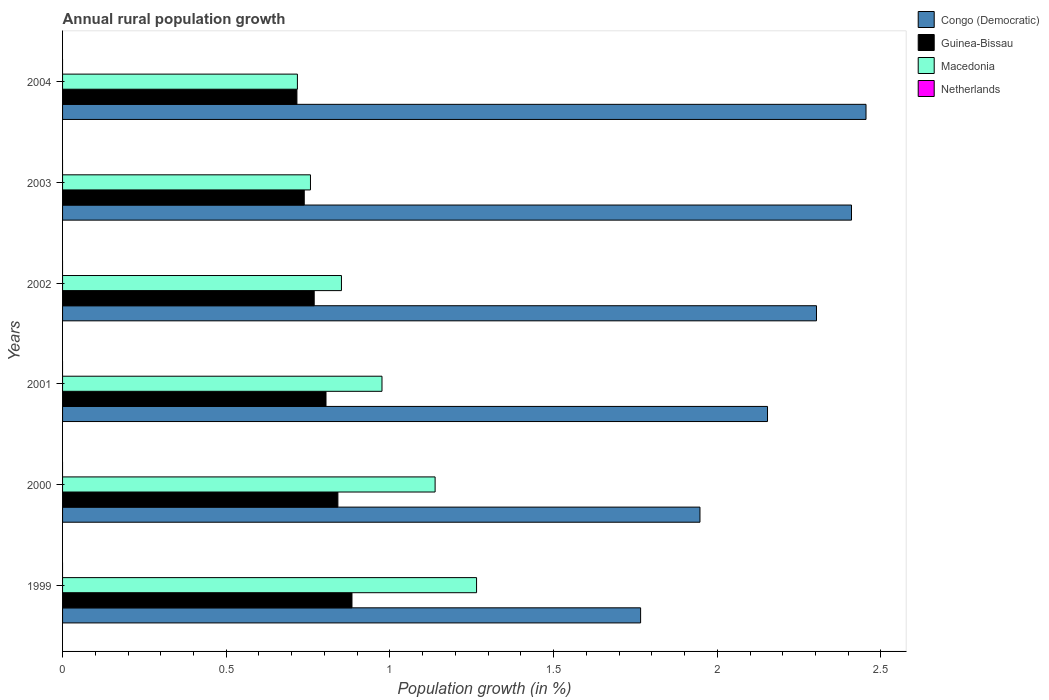How many bars are there on the 6th tick from the top?
Your response must be concise. 3. How many bars are there on the 2nd tick from the bottom?
Provide a short and direct response. 3. In how many cases, is the number of bars for a given year not equal to the number of legend labels?
Offer a very short reply. 6. What is the percentage of rural population growth in Netherlands in 2000?
Offer a very short reply. 0. Across all years, what is the maximum percentage of rural population growth in Macedonia?
Give a very brief answer. 1.26. Across all years, what is the minimum percentage of rural population growth in Congo (Democratic)?
Provide a short and direct response. 1.77. What is the total percentage of rural population growth in Guinea-Bissau in the graph?
Provide a succinct answer. 4.75. What is the difference between the percentage of rural population growth in Macedonia in 1999 and that in 2000?
Provide a succinct answer. 0.13. What is the difference between the percentage of rural population growth in Macedonia in 1999 and the percentage of rural population growth in Netherlands in 2003?
Make the answer very short. 1.26. What is the average percentage of rural population growth in Macedonia per year?
Your response must be concise. 0.95. In the year 2002, what is the difference between the percentage of rural population growth in Guinea-Bissau and percentage of rural population growth in Macedonia?
Your answer should be very brief. -0.08. In how many years, is the percentage of rural population growth in Guinea-Bissau greater than 1.1 %?
Keep it short and to the point. 0. What is the ratio of the percentage of rural population growth in Congo (Democratic) in 1999 to that in 2003?
Give a very brief answer. 0.73. Is the percentage of rural population growth in Macedonia in 2000 less than that in 2002?
Keep it short and to the point. No. Is the difference between the percentage of rural population growth in Guinea-Bissau in 2003 and 2004 greater than the difference between the percentage of rural population growth in Macedonia in 2003 and 2004?
Your response must be concise. No. What is the difference between the highest and the second highest percentage of rural population growth in Congo (Democratic)?
Make the answer very short. 0.04. What is the difference between the highest and the lowest percentage of rural population growth in Congo (Democratic)?
Offer a terse response. 0.69. In how many years, is the percentage of rural population growth in Guinea-Bissau greater than the average percentage of rural population growth in Guinea-Bissau taken over all years?
Your answer should be compact. 3. Is it the case that in every year, the sum of the percentage of rural population growth in Guinea-Bissau and percentage of rural population growth in Netherlands is greater than the sum of percentage of rural population growth in Macedonia and percentage of rural population growth in Congo (Democratic)?
Make the answer very short. No. Is it the case that in every year, the sum of the percentage of rural population growth in Guinea-Bissau and percentage of rural population growth in Netherlands is greater than the percentage of rural population growth in Congo (Democratic)?
Provide a succinct answer. No. Are all the bars in the graph horizontal?
Ensure brevity in your answer.  Yes. How many years are there in the graph?
Offer a terse response. 6. Does the graph contain any zero values?
Your answer should be compact. Yes. How are the legend labels stacked?
Make the answer very short. Vertical. What is the title of the graph?
Keep it short and to the point. Annual rural population growth. What is the label or title of the X-axis?
Provide a short and direct response. Population growth (in %). What is the label or title of the Y-axis?
Provide a succinct answer. Years. What is the Population growth (in %) of Congo (Democratic) in 1999?
Offer a terse response. 1.77. What is the Population growth (in %) in Guinea-Bissau in 1999?
Your answer should be compact. 0.88. What is the Population growth (in %) in Macedonia in 1999?
Ensure brevity in your answer.  1.26. What is the Population growth (in %) of Congo (Democratic) in 2000?
Your answer should be compact. 1.95. What is the Population growth (in %) of Guinea-Bissau in 2000?
Provide a short and direct response. 0.84. What is the Population growth (in %) of Macedonia in 2000?
Your answer should be compact. 1.14. What is the Population growth (in %) of Netherlands in 2000?
Offer a terse response. 0. What is the Population growth (in %) in Congo (Democratic) in 2001?
Your response must be concise. 2.15. What is the Population growth (in %) in Guinea-Bissau in 2001?
Provide a short and direct response. 0.8. What is the Population growth (in %) of Macedonia in 2001?
Your response must be concise. 0.98. What is the Population growth (in %) of Netherlands in 2001?
Your answer should be compact. 0. What is the Population growth (in %) in Congo (Democratic) in 2002?
Give a very brief answer. 2.3. What is the Population growth (in %) of Guinea-Bissau in 2002?
Your answer should be very brief. 0.77. What is the Population growth (in %) of Macedonia in 2002?
Your answer should be very brief. 0.85. What is the Population growth (in %) in Netherlands in 2002?
Make the answer very short. 0. What is the Population growth (in %) in Congo (Democratic) in 2003?
Keep it short and to the point. 2.41. What is the Population growth (in %) in Guinea-Bissau in 2003?
Your response must be concise. 0.74. What is the Population growth (in %) in Macedonia in 2003?
Make the answer very short. 0.76. What is the Population growth (in %) of Netherlands in 2003?
Keep it short and to the point. 0. What is the Population growth (in %) in Congo (Democratic) in 2004?
Make the answer very short. 2.45. What is the Population growth (in %) in Guinea-Bissau in 2004?
Provide a short and direct response. 0.72. What is the Population growth (in %) in Macedonia in 2004?
Offer a very short reply. 0.72. Across all years, what is the maximum Population growth (in %) in Congo (Democratic)?
Give a very brief answer. 2.45. Across all years, what is the maximum Population growth (in %) in Guinea-Bissau?
Offer a very short reply. 0.88. Across all years, what is the maximum Population growth (in %) in Macedonia?
Provide a short and direct response. 1.26. Across all years, what is the minimum Population growth (in %) of Congo (Democratic)?
Keep it short and to the point. 1.77. Across all years, what is the minimum Population growth (in %) of Guinea-Bissau?
Your answer should be very brief. 0.72. Across all years, what is the minimum Population growth (in %) in Macedonia?
Keep it short and to the point. 0.72. What is the total Population growth (in %) of Congo (Democratic) in the graph?
Offer a terse response. 13.03. What is the total Population growth (in %) in Guinea-Bissau in the graph?
Provide a short and direct response. 4.75. What is the total Population growth (in %) in Macedonia in the graph?
Your response must be concise. 5.71. What is the difference between the Population growth (in %) of Congo (Democratic) in 1999 and that in 2000?
Offer a very short reply. -0.18. What is the difference between the Population growth (in %) in Guinea-Bissau in 1999 and that in 2000?
Give a very brief answer. 0.04. What is the difference between the Population growth (in %) in Macedonia in 1999 and that in 2000?
Provide a short and direct response. 0.13. What is the difference between the Population growth (in %) of Congo (Democratic) in 1999 and that in 2001?
Keep it short and to the point. -0.39. What is the difference between the Population growth (in %) in Guinea-Bissau in 1999 and that in 2001?
Your answer should be very brief. 0.08. What is the difference between the Population growth (in %) in Macedonia in 1999 and that in 2001?
Ensure brevity in your answer.  0.29. What is the difference between the Population growth (in %) in Congo (Democratic) in 1999 and that in 2002?
Your response must be concise. -0.54. What is the difference between the Population growth (in %) of Guinea-Bissau in 1999 and that in 2002?
Provide a succinct answer. 0.12. What is the difference between the Population growth (in %) of Macedonia in 1999 and that in 2002?
Provide a short and direct response. 0.41. What is the difference between the Population growth (in %) of Congo (Democratic) in 1999 and that in 2003?
Offer a very short reply. -0.64. What is the difference between the Population growth (in %) of Guinea-Bissau in 1999 and that in 2003?
Your response must be concise. 0.15. What is the difference between the Population growth (in %) in Macedonia in 1999 and that in 2003?
Give a very brief answer. 0.51. What is the difference between the Population growth (in %) of Congo (Democratic) in 1999 and that in 2004?
Make the answer very short. -0.69. What is the difference between the Population growth (in %) of Guinea-Bissau in 1999 and that in 2004?
Your response must be concise. 0.17. What is the difference between the Population growth (in %) in Macedonia in 1999 and that in 2004?
Offer a terse response. 0.55. What is the difference between the Population growth (in %) of Congo (Democratic) in 2000 and that in 2001?
Ensure brevity in your answer.  -0.21. What is the difference between the Population growth (in %) of Guinea-Bissau in 2000 and that in 2001?
Make the answer very short. 0.04. What is the difference between the Population growth (in %) in Macedonia in 2000 and that in 2001?
Give a very brief answer. 0.16. What is the difference between the Population growth (in %) of Congo (Democratic) in 2000 and that in 2002?
Your answer should be compact. -0.36. What is the difference between the Population growth (in %) of Guinea-Bissau in 2000 and that in 2002?
Offer a very short reply. 0.07. What is the difference between the Population growth (in %) of Macedonia in 2000 and that in 2002?
Your response must be concise. 0.29. What is the difference between the Population growth (in %) of Congo (Democratic) in 2000 and that in 2003?
Give a very brief answer. -0.46. What is the difference between the Population growth (in %) of Guinea-Bissau in 2000 and that in 2003?
Make the answer very short. 0.1. What is the difference between the Population growth (in %) of Macedonia in 2000 and that in 2003?
Your answer should be compact. 0.38. What is the difference between the Population growth (in %) in Congo (Democratic) in 2000 and that in 2004?
Keep it short and to the point. -0.51. What is the difference between the Population growth (in %) in Guinea-Bissau in 2000 and that in 2004?
Keep it short and to the point. 0.13. What is the difference between the Population growth (in %) of Macedonia in 2000 and that in 2004?
Make the answer very short. 0.42. What is the difference between the Population growth (in %) of Congo (Democratic) in 2001 and that in 2002?
Provide a succinct answer. -0.15. What is the difference between the Population growth (in %) in Guinea-Bissau in 2001 and that in 2002?
Make the answer very short. 0.04. What is the difference between the Population growth (in %) in Macedonia in 2001 and that in 2002?
Provide a succinct answer. 0.12. What is the difference between the Population growth (in %) in Congo (Democratic) in 2001 and that in 2003?
Offer a terse response. -0.26. What is the difference between the Population growth (in %) in Guinea-Bissau in 2001 and that in 2003?
Make the answer very short. 0.07. What is the difference between the Population growth (in %) in Macedonia in 2001 and that in 2003?
Provide a short and direct response. 0.22. What is the difference between the Population growth (in %) in Congo (Democratic) in 2001 and that in 2004?
Your answer should be very brief. -0.3. What is the difference between the Population growth (in %) of Guinea-Bissau in 2001 and that in 2004?
Your answer should be very brief. 0.09. What is the difference between the Population growth (in %) of Macedonia in 2001 and that in 2004?
Ensure brevity in your answer.  0.26. What is the difference between the Population growth (in %) in Congo (Democratic) in 2002 and that in 2003?
Your answer should be compact. -0.11. What is the difference between the Population growth (in %) of Guinea-Bissau in 2002 and that in 2003?
Ensure brevity in your answer.  0.03. What is the difference between the Population growth (in %) of Macedonia in 2002 and that in 2003?
Offer a very short reply. 0.09. What is the difference between the Population growth (in %) of Congo (Democratic) in 2002 and that in 2004?
Provide a short and direct response. -0.15. What is the difference between the Population growth (in %) in Guinea-Bissau in 2002 and that in 2004?
Provide a short and direct response. 0.05. What is the difference between the Population growth (in %) in Macedonia in 2002 and that in 2004?
Your answer should be compact. 0.13. What is the difference between the Population growth (in %) in Congo (Democratic) in 2003 and that in 2004?
Your response must be concise. -0.04. What is the difference between the Population growth (in %) in Guinea-Bissau in 2003 and that in 2004?
Your answer should be compact. 0.02. What is the difference between the Population growth (in %) of Macedonia in 2003 and that in 2004?
Make the answer very short. 0.04. What is the difference between the Population growth (in %) of Congo (Democratic) in 1999 and the Population growth (in %) of Guinea-Bissau in 2000?
Provide a succinct answer. 0.92. What is the difference between the Population growth (in %) of Congo (Democratic) in 1999 and the Population growth (in %) of Macedonia in 2000?
Your response must be concise. 0.63. What is the difference between the Population growth (in %) of Guinea-Bissau in 1999 and the Population growth (in %) of Macedonia in 2000?
Provide a succinct answer. -0.25. What is the difference between the Population growth (in %) of Congo (Democratic) in 1999 and the Population growth (in %) of Guinea-Bissau in 2001?
Give a very brief answer. 0.96. What is the difference between the Population growth (in %) of Congo (Democratic) in 1999 and the Population growth (in %) of Macedonia in 2001?
Your answer should be compact. 0.79. What is the difference between the Population growth (in %) of Guinea-Bissau in 1999 and the Population growth (in %) of Macedonia in 2001?
Give a very brief answer. -0.09. What is the difference between the Population growth (in %) in Congo (Democratic) in 1999 and the Population growth (in %) in Guinea-Bissau in 2002?
Provide a succinct answer. 1. What is the difference between the Population growth (in %) of Congo (Democratic) in 1999 and the Population growth (in %) of Macedonia in 2002?
Offer a terse response. 0.91. What is the difference between the Population growth (in %) of Guinea-Bissau in 1999 and the Population growth (in %) of Macedonia in 2002?
Keep it short and to the point. 0.03. What is the difference between the Population growth (in %) in Congo (Democratic) in 1999 and the Population growth (in %) in Guinea-Bissau in 2003?
Make the answer very short. 1.03. What is the difference between the Population growth (in %) of Congo (Democratic) in 1999 and the Population growth (in %) of Macedonia in 2003?
Keep it short and to the point. 1.01. What is the difference between the Population growth (in %) in Guinea-Bissau in 1999 and the Population growth (in %) in Macedonia in 2003?
Ensure brevity in your answer.  0.13. What is the difference between the Population growth (in %) in Congo (Democratic) in 1999 and the Population growth (in %) in Guinea-Bissau in 2004?
Your answer should be very brief. 1.05. What is the difference between the Population growth (in %) in Congo (Democratic) in 1999 and the Population growth (in %) in Macedonia in 2004?
Provide a short and direct response. 1.05. What is the difference between the Population growth (in %) of Congo (Democratic) in 2000 and the Population growth (in %) of Guinea-Bissau in 2001?
Offer a very short reply. 1.14. What is the difference between the Population growth (in %) in Congo (Democratic) in 2000 and the Population growth (in %) in Macedonia in 2001?
Keep it short and to the point. 0.97. What is the difference between the Population growth (in %) in Guinea-Bissau in 2000 and the Population growth (in %) in Macedonia in 2001?
Make the answer very short. -0.13. What is the difference between the Population growth (in %) in Congo (Democratic) in 2000 and the Population growth (in %) in Guinea-Bissau in 2002?
Give a very brief answer. 1.18. What is the difference between the Population growth (in %) in Congo (Democratic) in 2000 and the Population growth (in %) in Macedonia in 2002?
Your answer should be very brief. 1.1. What is the difference between the Population growth (in %) of Guinea-Bissau in 2000 and the Population growth (in %) of Macedonia in 2002?
Your response must be concise. -0.01. What is the difference between the Population growth (in %) in Congo (Democratic) in 2000 and the Population growth (in %) in Guinea-Bissau in 2003?
Your response must be concise. 1.21. What is the difference between the Population growth (in %) of Congo (Democratic) in 2000 and the Population growth (in %) of Macedonia in 2003?
Keep it short and to the point. 1.19. What is the difference between the Population growth (in %) of Guinea-Bissau in 2000 and the Population growth (in %) of Macedonia in 2003?
Your response must be concise. 0.08. What is the difference between the Population growth (in %) of Congo (Democratic) in 2000 and the Population growth (in %) of Guinea-Bissau in 2004?
Offer a very short reply. 1.23. What is the difference between the Population growth (in %) in Congo (Democratic) in 2000 and the Population growth (in %) in Macedonia in 2004?
Offer a very short reply. 1.23. What is the difference between the Population growth (in %) in Guinea-Bissau in 2000 and the Population growth (in %) in Macedonia in 2004?
Offer a terse response. 0.12. What is the difference between the Population growth (in %) of Congo (Democratic) in 2001 and the Population growth (in %) of Guinea-Bissau in 2002?
Offer a very short reply. 1.38. What is the difference between the Population growth (in %) of Congo (Democratic) in 2001 and the Population growth (in %) of Macedonia in 2002?
Your answer should be compact. 1.3. What is the difference between the Population growth (in %) of Guinea-Bissau in 2001 and the Population growth (in %) of Macedonia in 2002?
Give a very brief answer. -0.05. What is the difference between the Population growth (in %) in Congo (Democratic) in 2001 and the Population growth (in %) in Guinea-Bissau in 2003?
Offer a terse response. 1.42. What is the difference between the Population growth (in %) in Congo (Democratic) in 2001 and the Population growth (in %) in Macedonia in 2003?
Give a very brief answer. 1.4. What is the difference between the Population growth (in %) of Guinea-Bissau in 2001 and the Population growth (in %) of Macedonia in 2003?
Keep it short and to the point. 0.05. What is the difference between the Population growth (in %) of Congo (Democratic) in 2001 and the Population growth (in %) of Guinea-Bissau in 2004?
Your response must be concise. 1.44. What is the difference between the Population growth (in %) of Congo (Democratic) in 2001 and the Population growth (in %) of Macedonia in 2004?
Your answer should be compact. 1.44. What is the difference between the Population growth (in %) in Guinea-Bissau in 2001 and the Population growth (in %) in Macedonia in 2004?
Provide a short and direct response. 0.09. What is the difference between the Population growth (in %) in Congo (Democratic) in 2002 and the Population growth (in %) in Guinea-Bissau in 2003?
Offer a very short reply. 1.56. What is the difference between the Population growth (in %) in Congo (Democratic) in 2002 and the Population growth (in %) in Macedonia in 2003?
Provide a short and direct response. 1.55. What is the difference between the Population growth (in %) of Guinea-Bissau in 2002 and the Population growth (in %) of Macedonia in 2003?
Offer a very short reply. 0.01. What is the difference between the Population growth (in %) of Congo (Democratic) in 2002 and the Population growth (in %) of Guinea-Bissau in 2004?
Provide a succinct answer. 1.59. What is the difference between the Population growth (in %) of Congo (Democratic) in 2002 and the Population growth (in %) of Macedonia in 2004?
Give a very brief answer. 1.59. What is the difference between the Population growth (in %) in Guinea-Bissau in 2002 and the Population growth (in %) in Macedonia in 2004?
Your answer should be very brief. 0.05. What is the difference between the Population growth (in %) in Congo (Democratic) in 2003 and the Population growth (in %) in Guinea-Bissau in 2004?
Provide a succinct answer. 1.69. What is the difference between the Population growth (in %) in Congo (Democratic) in 2003 and the Population growth (in %) in Macedonia in 2004?
Offer a very short reply. 1.69. What is the difference between the Population growth (in %) of Guinea-Bissau in 2003 and the Population growth (in %) of Macedonia in 2004?
Give a very brief answer. 0.02. What is the average Population growth (in %) in Congo (Democratic) per year?
Offer a very short reply. 2.17. What is the average Population growth (in %) of Guinea-Bissau per year?
Provide a short and direct response. 0.79. What is the average Population growth (in %) in Macedonia per year?
Give a very brief answer. 0.95. What is the average Population growth (in %) in Netherlands per year?
Your answer should be very brief. 0. In the year 1999, what is the difference between the Population growth (in %) of Congo (Democratic) and Population growth (in %) of Guinea-Bissau?
Give a very brief answer. 0.88. In the year 1999, what is the difference between the Population growth (in %) in Congo (Democratic) and Population growth (in %) in Macedonia?
Ensure brevity in your answer.  0.5. In the year 1999, what is the difference between the Population growth (in %) in Guinea-Bissau and Population growth (in %) in Macedonia?
Provide a short and direct response. -0.38. In the year 2000, what is the difference between the Population growth (in %) of Congo (Democratic) and Population growth (in %) of Guinea-Bissau?
Your answer should be compact. 1.11. In the year 2000, what is the difference between the Population growth (in %) in Congo (Democratic) and Population growth (in %) in Macedonia?
Keep it short and to the point. 0.81. In the year 2000, what is the difference between the Population growth (in %) of Guinea-Bissau and Population growth (in %) of Macedonia?
Offer a very short reply. -0.3. In the year 2001, what is the difference between the Population growth (in %) of Congo (Democratic) and Population growth (in %) of Guinea-Bissau?
Keep it short and to the point. 1.35. In the year 2001, what is the difference between the Population growth (in %) of Congo (Democratic) and Population growth (in %) of Macedonia?
Make the answer very short. 1.18. In the year 2001, what is the difference between the Population growth (in %) of Guinea-Bissau and Population growth (in %) of Macedonia?
Keep it short and to the point. -0.17. In the year 2002, what is the difference between the Population growth (in %) in Congo (Democratic) and Population growth (in %) in Guinea-Bissau?
Offer a terse response. 1.53. In the year 2002, what is the difference between the Population growth (in %) of Congo (Democratic) and Population growth (in %) of Macedonia?
Offer a terse response. 1.45. In the year 2002, what is the difference between the Population growth (in %) of Guinea-Bissau and Population growth (in %) of Macedonia?
Provide a short and direct response. -0.08. In the year 2003, what is the difference between the Population growth (in %) of Congo (Democratic) and Population growth (in %) of Guinea-Bissau?
Your answer should be very brief. 1.67. In the year 2003, what is the difference between the Population growth (in %) of Congo (Democratic) and Population growth (in %) of Macedonia?
Give a very brief answer. 1.65. In the year 2003, what is the difference between the Population growth (in %) of Guinea-Bissau and Population growth (in %) of Macedonia?
Ensure brevity in your answer.  -0.02. In the year 2004, what is the difference between the Population growth (in %) of Congo (Democratic) and Population growth (in %) of Guinea-Bissau?
Make the answer very short. 1.74. In the year 2004, what is the difference between the Population growth (in %) of Congo (Democratic) and Population growth (in %) of Macedonia?
Provide a succinct answer. 1.74. In the year 2004, what is the difference between the Population growth (in %) of Guinea-Bissau and Population growth (in %) of Macedonia?
Give a very brief answer. -0. What is the ratio of the Population growth (in %) of Congo (Democratic) in 1999 to that in 2000?
Your answer should be compact. 0.91. What is the ratio of the Population growth (in %) in Guinea-Bissau in 1999 to that in 2000?
Your answer should be compact. 1.05. What is the ratio of the Population growth (in %) of Macedonia in 1999 to that in 2000?
Your answer should be compact. 1.11. What is the ratio of the Population growth (in %) in Congo (Democratic) in 1999 to that in 2001?
Your answer should be very brief. 0.82. What is the ratio of the Population growth (in %) in Guinea-Bissau in 1999 to that in 2001?
Offer a very short reply. 1.1. What is the ratio of the Population growth (in %) in Macedonia in 1999 to that in 2001?
Make the answer very short. 1.3. What is the ratio of the Population growth (in %) in Congo (Democratic) in 1999 to that in 2002?
Keep it short and to the point. 0.77. What is the ratio of the Population growth (in %) of Guinea-Bissau in 1999 to that in 2002?
Your answer should be compact. 1.15. What is the ratio of the Population growth (in %) of Macedonia in 1999 to that in 2002?
Provide a succinct answer. 1.48. What is the ratio of the Population growth (in %) of Congo (Democratic) in 1999 to that in 2003?
Give a very brief answer. 0.73. What is the ratio of the Population growth (in %) in Guinea-Bissau in 1999 to that in 2003?
Ensure brevity in your answer.  1.2. What is the ratio of the Population growth (in %) of Macedonia in 1999 to that in 2003?
Make the answer very short. 1.67. What is the ratio of the Population growth (in %) in Congo (Democratic) in 1999 to that in 2004?
Provide a short and direct response. 0.72. What is the ratio of the Population growth (in %) of Guinea-Bissau in 1999 to that in 2004?
Make the answer very short. 1.23. What is the ratio of the Population growth (in %) in Macedonia in 1999 to that in 2004?
Keep it short and to the point. 1.76. What is the ratio of the Population growth (in %) in Congo (Democratic) in 2000 to that in 2001?
Ensure brevity in your answer.  0.9. What is the ratio of the Population growth (in %) of Guinea-Bissau in 2000 to that in 2001?
Your response must be concise. 1.05. What is the ratio of the Population growth (in %) in Macedonia in 2000 to that in 2001?
Ensure brevity in your answer.  1.17. What is the ratio of the Population growth (in %) in Congo (Democratic) in 2000 to that in 2002?
Give a very brief answer. 0.85. What is the ratio of the Population growth (in %) of Guinea-Bissau in 2000 to that in 2002?
Give a very brief answer. 1.09. What is the ratio of the Population growth (in %) in Macedonia in 2000 to that in 2002?
Offer a very short reply. 1.34. What is the ratio of the Population growth (in %) of Congo (Democratic) in 2000 to that in 2003?
Keep it short and to the point. 0.81. What is the ratio of the Population growth (in %) in Guinea-Bissau in 2000 to that in 2003?
Offer a terse response. 1.14. What is the ratio of the Population growth (in %) in Macedonia in 2000 to that in 2003?
Offer a terse response. 1.5. What is the ratio of the Population growth (in %) in Congo (Democratic) in 2000 to that in 2004?
Your answer should be very brief. 0.79. What is the ratio of the Population growth (in %) in Guinea-Bissau in 2000 to that in 2004?
Give a very brief answer. 1.17. What is the ratio of the Population growth (in %) in Macedonia in 2000 to that in 2004?
Your answer should be very brief. 1.59. What is the ratio of the Population growth (in %) of Congo (Democratic) in 2001 to that in 2002?
Offer a very short reply. 0.94. What is the ratio of the Population growth (in %) in Guinea-Bissau in 2001 to that in 2002?
Provide a short and direct response. 1.05. What is the ratio of the Population growth (in %) in Macedonia in 2001 to that in 2002?
Keep it short and to the point. 1.15. What is the ratio of the Population growth (in %) in Congo (Democratic) in 2001 to that in 2003?
Your answer should be very brief. 0.89. What is the ratio of the Population growth (in %) in Guinea-Bissau in 2001 to that in 2003?
Ensure brevity in your answer.  1.09. What is the ratio of the Population growth (in %) in Macedonia in 2001 to that in 2003?
Your answer should be very brief. 1.29. What is the ratio of the Population growth (in %) of Congo (Democratic) in 2001 to that in 2004?
Provide a succinct answer. 0.88. What is the ratio of the Population growth (in %) of Guinea-Bissau in 2001 to that in 2004?
Offer a terse response. 1.12. What is the ratio of the Population growth (in %) in Macedonia in 2001 to that in 2004?
Keep it short and to the point. 1.36. What is the ratio of the Population growth (in %) in Congo (Democratic) in 2002 to that in 2003?
Your response must be concise. 0.96. What is the ratio of the Population growth (in %) in Guinea-Bissau in 2002 to that in 2003?
Keep it short and to the point. 1.04. What is the ratio of the Population growth (in %) in Macedonia in 2002 to that in 2003?
Offer a terse response. 1.12. What is the ratio of the Population growth (in %) of Congo (Democratic) in 2002 to that in 2004?
Make the answer very short. 0.94. What is the ratio of the Population growth (in %) in Guinea-Bissau in 2002 to that in 2004?
Provide a short and direct response. 1.07. What is the ratio of the Population growth (in %) in Macedonia in 2002 to that in 2004?
Provide a short and direct response. 1.19. What is the ratio of the Population growth (in %) in Congo (Democratic) in 2003 to that in 2004?
Offer a very short reply. 0.98. What is the ratio of the Population growth (in %) of Guinea-Bissau in 2003 to that in 2004?
Keep it short and to the point. 1.03. What is the ratio of the Population growth (in %) of Macedonia in 2003 to that in 2004?
Give a very brief answer. 1.06. What is the difference between the highest and the second highest Population growth (in %) of Congo (Democratic)?
Your answer should be very brief. 0.04. What is the difference between the highest and the second highest Population growth (in %) of Guinea-Bissau?
Offer a terse response. 0.04. What is the difference between the highest and the second highest Population growth (in %) of Macedonia?
Give a very brief answer. 0.13. What is the difference between the highest and the lowest Population growth (in %) in Congo (Democratic)?
Offer a terse response. 0.69. What is the difference between the highest and the lowest Population growth (in %) of Guinea-Bissau?
Give a very brief answer. 0.17. What is the difference between the highest and the lowest Population growth (in %) of Macedonia?
Provide a short and direct response. 0.55. 